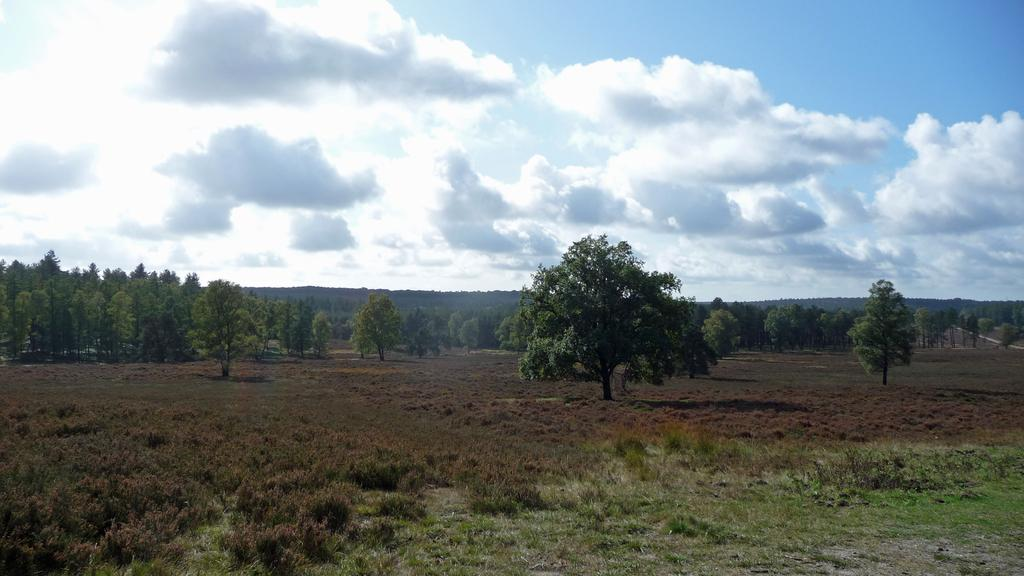What type of vegetation is present in the foreground of the picture? There are shrubs and grass in the foreground of the picture. What can be seen in the center of the picture? There are trees and shrubs in the center of the picture. How would you describe the weather in the image? The sky is sunny, indicating a clear and likely warm day. What type of afterthought is visible in the image? There is no afterthought present in the image; it features natural elements such as shrubs, grass, trees, and a sunny sky. What kind of test can be seen being conducted in the image? There is no test being conducted in the image; it is a scene of natural elements. 